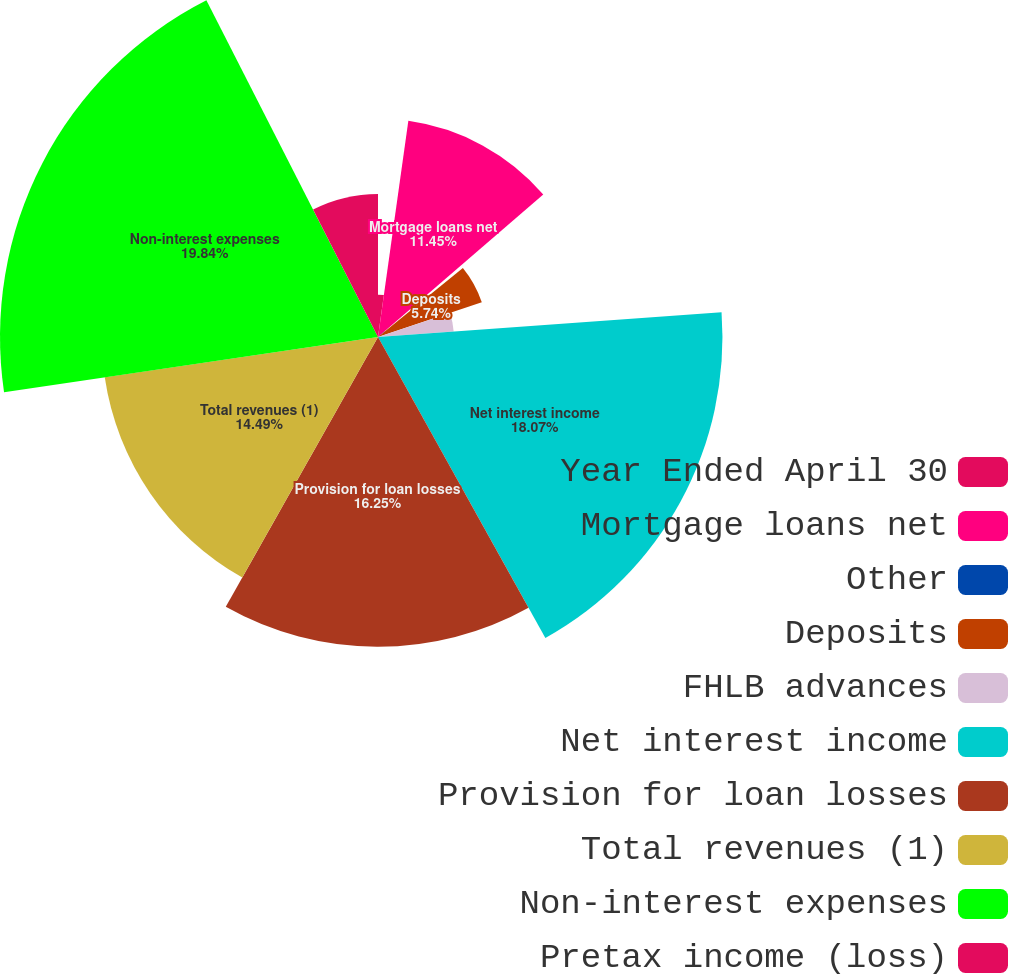Convert chart to OTSL. <chart><loc_0><loc_0><loc_500><loc_500><pie_chart><fcel>Year Ended April 30<fcel>Mortgage loans net<fcel>Other<fcel>Deposits<fcel>FHLB advances<fcel>Net interest income<fcel>Provision for loan losses<fcel>Total revenues (1)<fcel>Non-interest expenses<fcel>Pretax income (loss)<nl><fcel>2.22%<fcel>11.45%<fcel>0.46%<fcel>5.74%<fcel>3.98%<fcel>18.07%<fcel>16.25%<fcel>14.49%<fcel>19.83%<fcel>7.5%<nl></chart> 